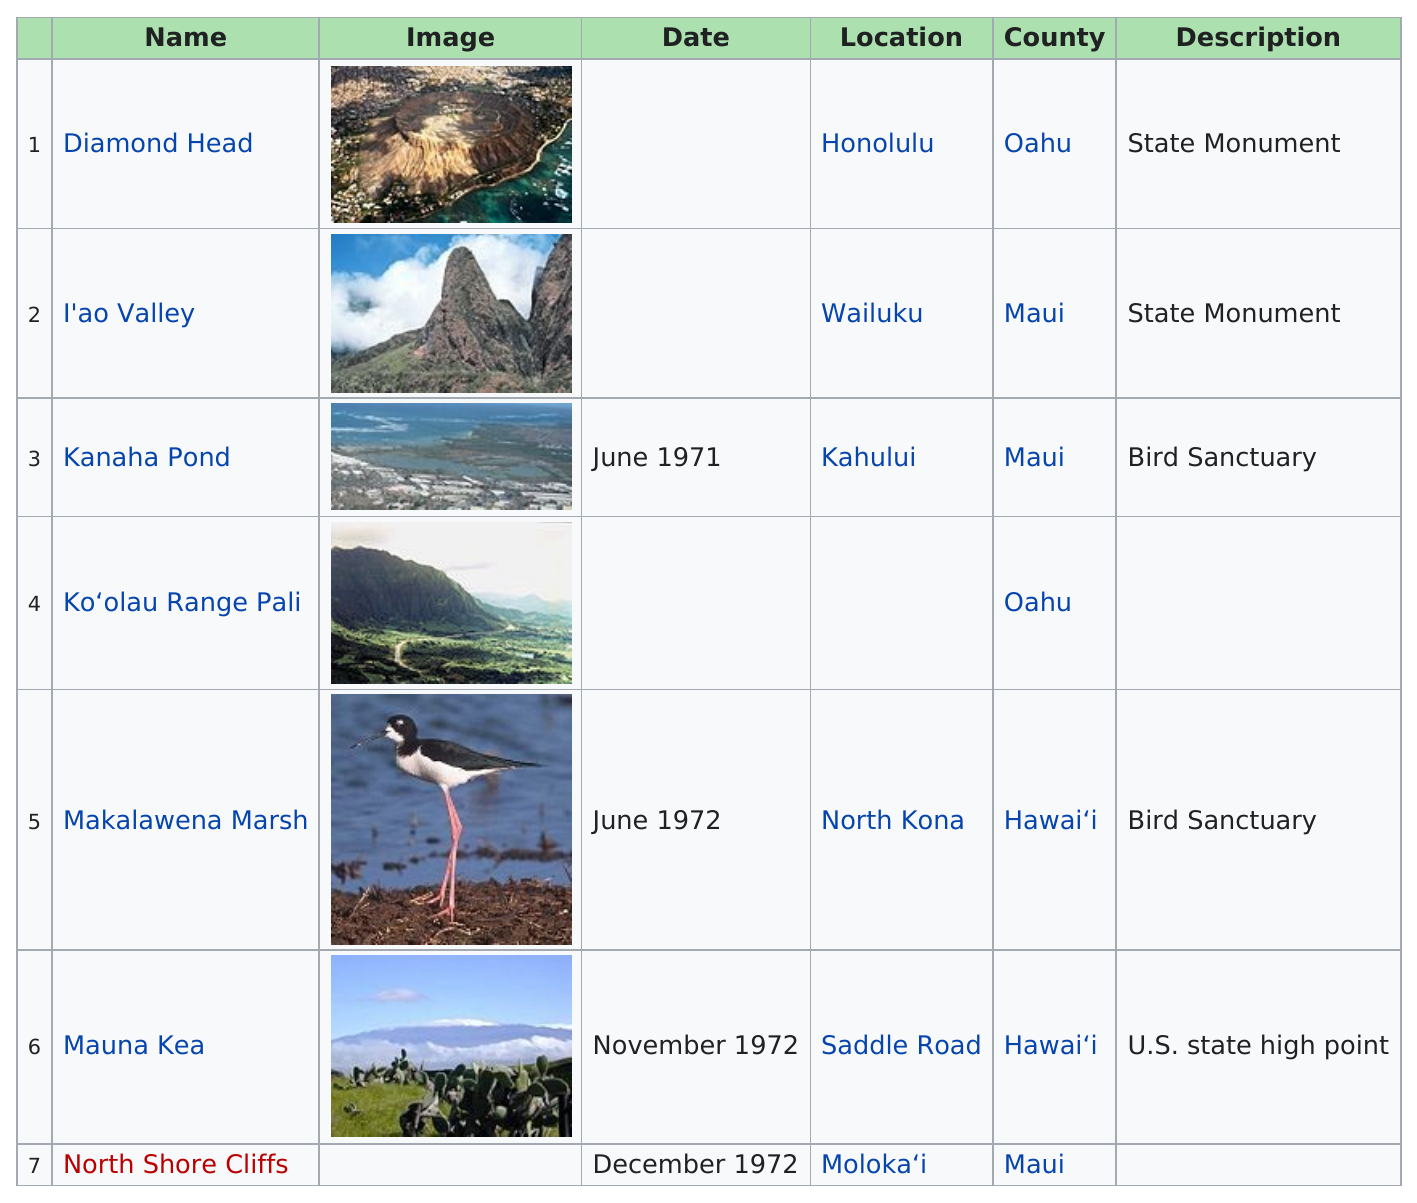Highlight a few significant elements in this photo. There are 2 state monuments in total. There are 3 landmarks located in Maui. Maui is the county that is prominently featured on the chart. The only name listed without a location is Koʻolau Range Pali. There were three dates in 1972. 